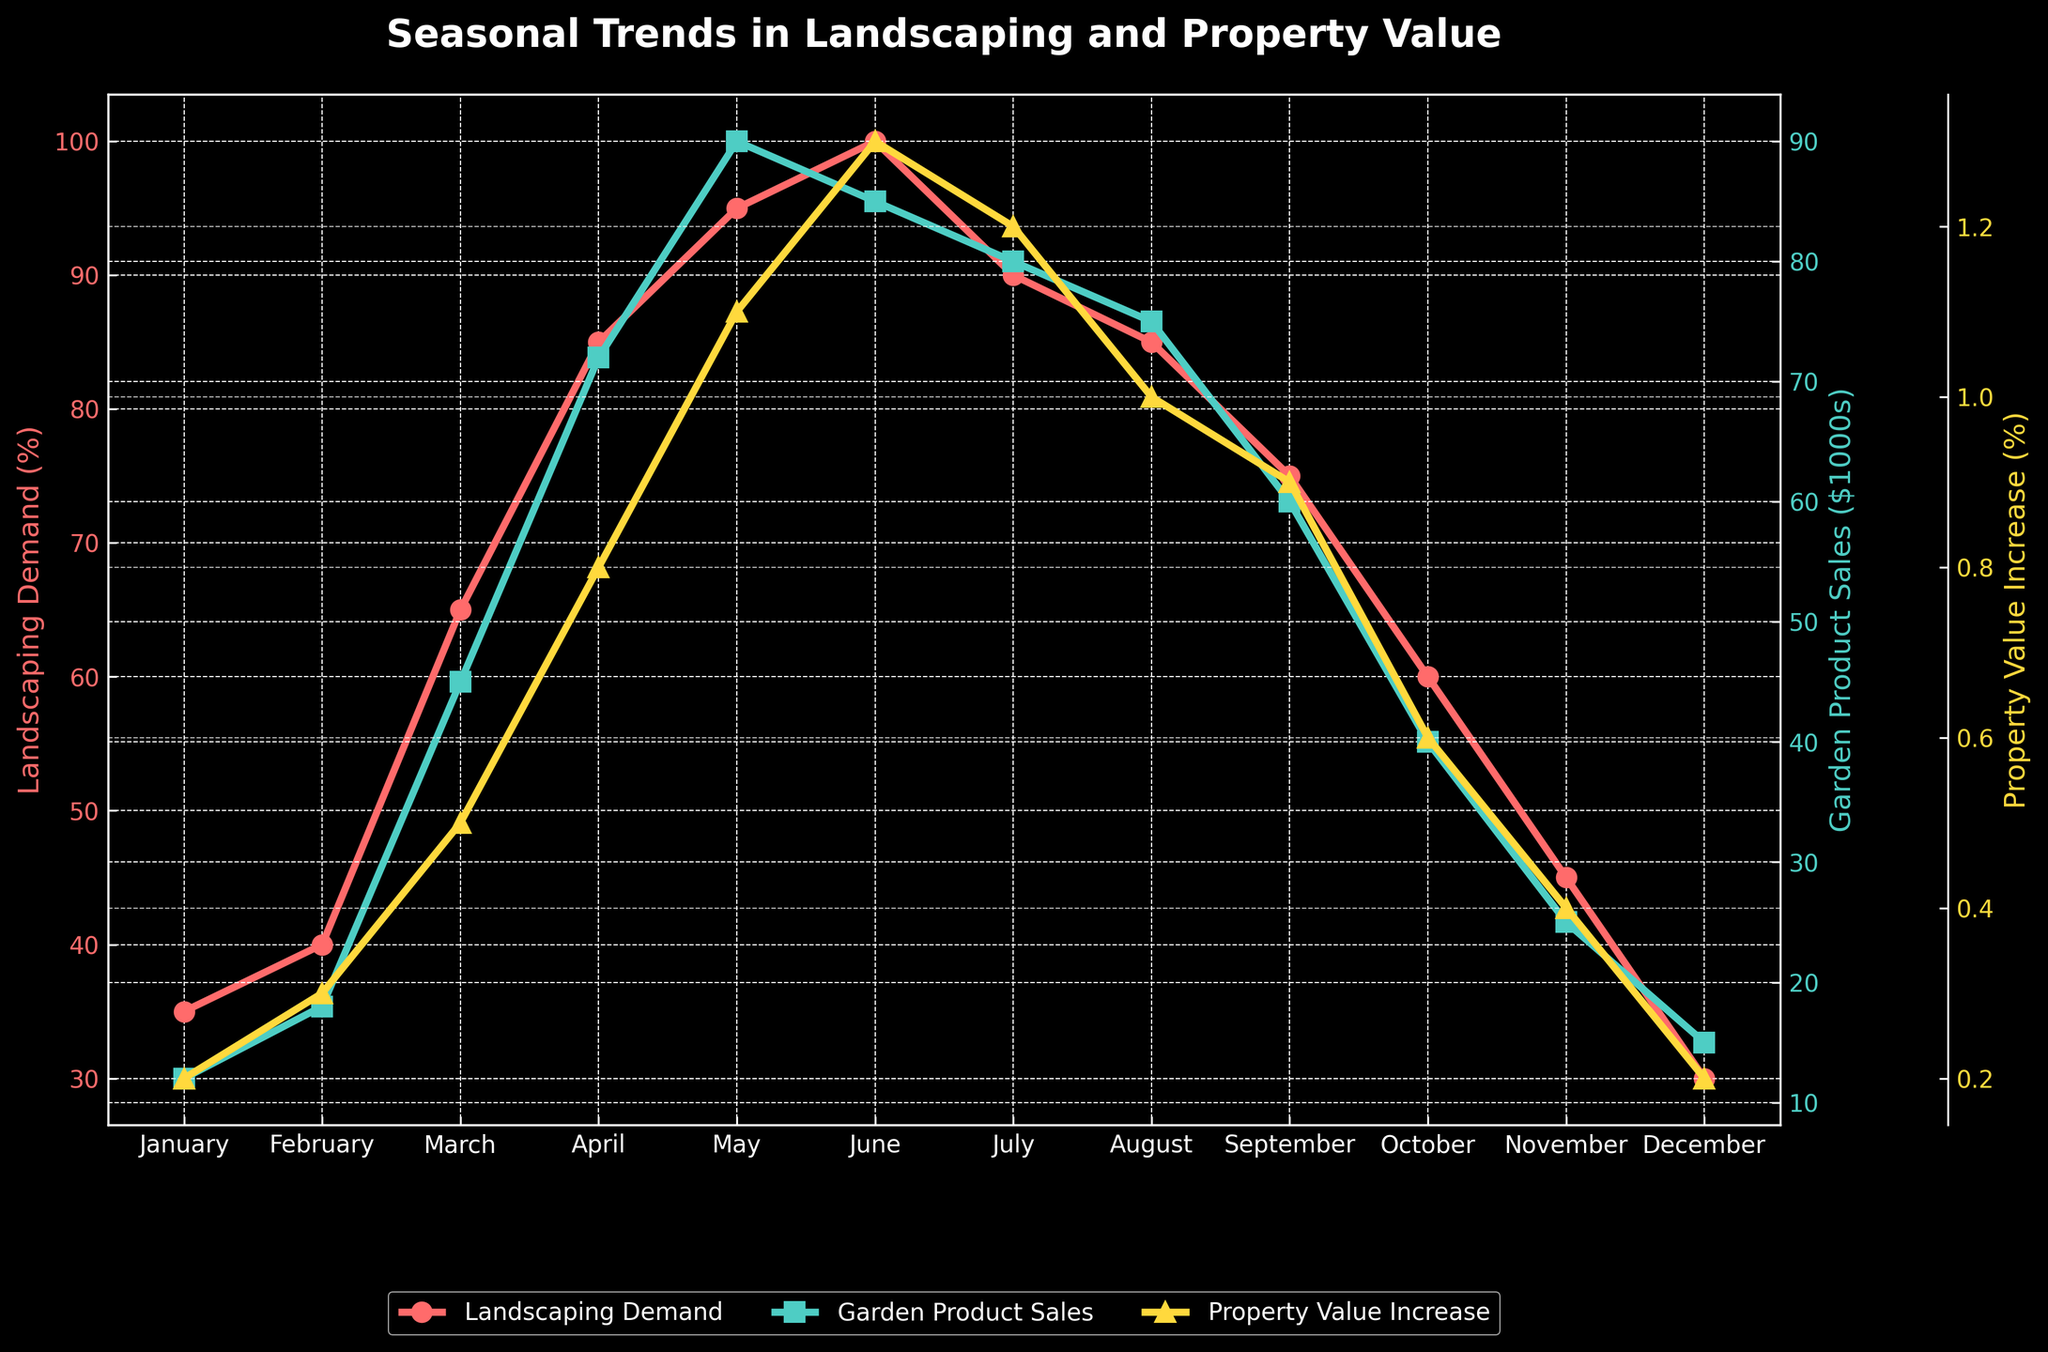How does the landscaping services demand change from January to June? To determine this, we refer to the red line in the figure representing landscaping services demand. Starting in January at 35%, the demand steadily increases each month, reaching its peak at 100% in June.
Answer: The demand increases from 35% to 100% What is the difference in garden product sales between the highest and lowest months? Identify the green line representing garden product sales in the figure. The highest sales occur in May ($90k) and the lowest in January ($12k). Subtracting January from May: $90k - $12k = $78k.
Answer: $78k Which month shows the highest property value increase percentage, and what is that value? The yellow line represents the property value increase. The highest percentage is seen in June at 1.3%.
Answer: June, 1.3% Between which consecutive months is the largest drop in landscaping services demand observed? Refer to the red line and find the sharpest decline in demand. The steepest drop is from June (100%) to July (90%), a 10% drop.
Answer: June to July, 10% Which two months show an equal percentage increase in property value? The yellow line shows property value increases. Both January and December show a 0.2% increase.
Answer: January and December How do the garden product sales in October compare to those in February? The green line indicates sales data. October has $40k in sales, while February has $18k. October's sales are higher by $22k.
Answer: October sales are $22k higher What is the total increase in property value percentages observed from March to May? Calculate individually: March (0.5%) + April (0.8%) + May (1.1%). Summing them: 0.5 + 0.8 + 1.1 = 2.4%.
Answer: 2.4% Which month has the highest correlation of a peak in all three variables? Examine the peaks in the red (demand), green (sales), and yellow (value) lines. May shows a collective peak: 95% demand, $90k sales, and 1.1% value increase.
Answer: May In which month is the property value increase closest to 1.0%? Look at the yellow line for values around 1.0%. August shows a 1.0% increase.
Answer: August What is the rate of increase in landscaping demand from February to March? Demand in February is 40% and in March 65%. The increase rate is (65% - 40%) / 40% * 100 = 62.5%.
Answer: 62.5% 